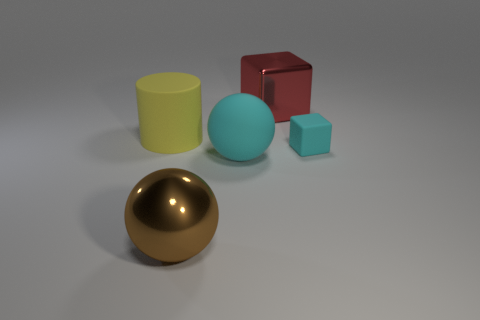Is there anything else that is the same size as the cyan block?
Your response must be concise. No. Are there any yellow rubber cylinders behind the tiny cube?
Your response must be concise. Yes. There is a big matte thing behind the cube in front of the metallic thing that is behind the large rubber cylinder; what is its color?
Make the answer very short. Yellow. What shape is the yellow rubber object that is the same size as the brown metal object?
Offer a very short reply. Cylinder. Is the number of cyan matte blocks greater than the number of blocks?
Give a very brief answer. No. There is a big sphere that is behind the large brown metallic ball; are there any matte balls that are in front of it?
Offer a terse response. No. What is the color of the other thing that is the same shape as the big brown object?
Give a very brief answer. Cyan. Is there anything else that is the same shape as the yellow object?
Make the answer very short. No. The small block that is made of the same material as the cylinder is what color?
Keep it short and to the point. Cyan. There is a matte thing on the right side of the metal cube behind the yellow cylinder; are there any big red metal objects that are behind it?
Your answer should be very brief. Yes. 